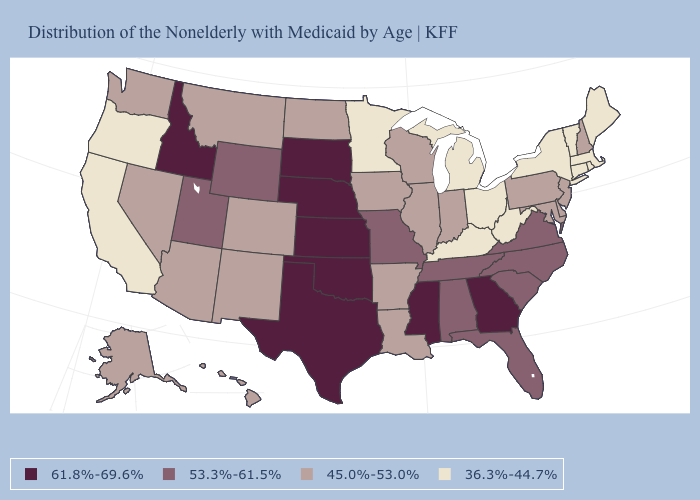What is the value of New York?
Be succinct. 36.3%-44.7%. Among the states that border North Carolina , which have the lowest value?
Give a very brief answer. South Carolina, Tennessee, Virginia. Does the first symbol in the legend represent the smallest category?
Short answer required. No. How many symbols are there in the legend?
Write a very short answer. 4. Name the states that have a value in the range 53.3%-61.5%?
Be succinct. Alabama, Florida, Missouri, North Carolina, South Carolina, Tennessee, Utah, Virginia, Wyoming. Which states have the lowest value in the USA?
Concise answer only. California, Connecticut, Kentucky, Maine, Massachusetts, Michigan, Minnesota, New York, Ohio, Oregon, Rhode Island, Vermont, West Virginia. Among the states that border Washington , does Idaho have the highest value?
Keep it brief. Yes. Name the states that have a value in the range 53.3%-61.5%?
Concise answer only. Alabama, Florida, Missouri, North Carolina, South Carolina, Tennessee, Utah, Virginia, Wyoming. Which states have the lowest value in the Northeast?
Answer briefly. Connecticut, Maine, Massachusetts, New York, Rhode Island, Vermont. Does Massachusetts have the lowest value in the USA?
Quick response, please. Yes. Which states hav the highest value in the MidWest?
Answer briefly. Kansas, Nebraska, South Dakota. What is the value of Montana?
Keep it brief. 45.0%-53.0%. What is the highest value in the USA?
Answer briefly. 61.8%-69.6%. Among the states that border New Hampshire , which have the lowest value?
Concise answer only. Maine, Massachusetts, Vermont. Name the states that have a value in the range 61.8%-69.6%?
Concise answer only. Georgia, Idaho, Kansas, Mississippi, Nebraska, Oklahoma, South Dakota, Texas. 